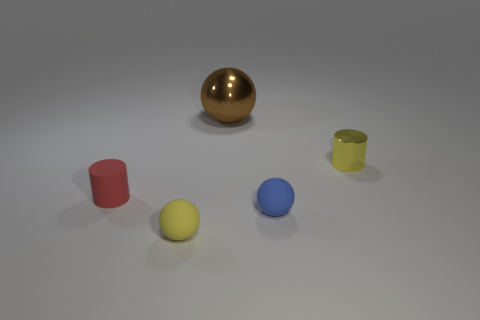Subtract all brown cylinders. Subtract all purple balls. How many cylinders are left? 2 Add 3 green shiny spheres. How many objects exist? 8 Subtract all cylinders. How many objects are left? 3 Add 1 large metal cylinders. How many large metal cylinders exist? 1 Subtract 1 brown balls. How many objects are left? 4 Subtract all metallic cylinders. Subtract all tiny things. How many objects are left? 0 Add 5 tiny blue objects. How many tiny blue objects are left? 6 